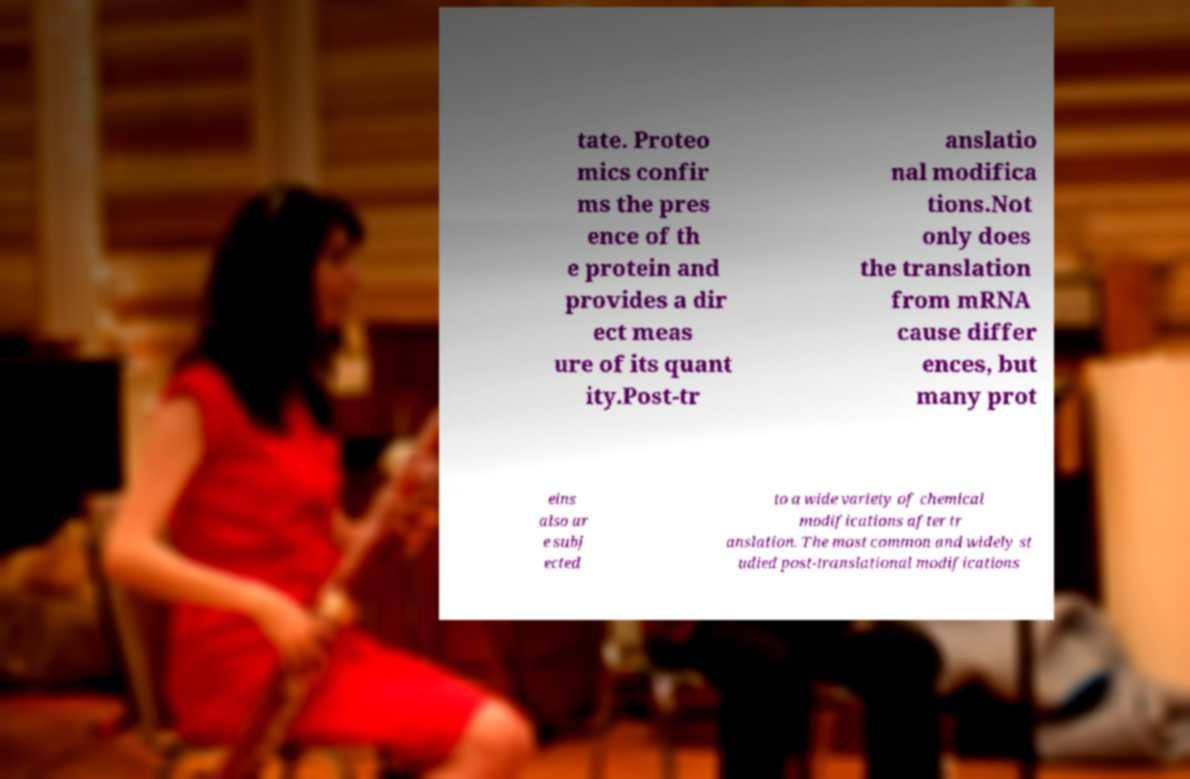There's text embedded in this image that I need extracted. Can you transcribe it verbatim? tate. Proteo mics confir ms the pres ence of th e protein and provides a dir ect meas ure of its quant ity.Post-tr anslatio nal modifica tions.Not only does the translation from mRNA cause differ ences, but many prot eins also ar e subj ected to a wide variety of chemical modifications after tr anslation. The most common and widely st udied post-translational modifications 